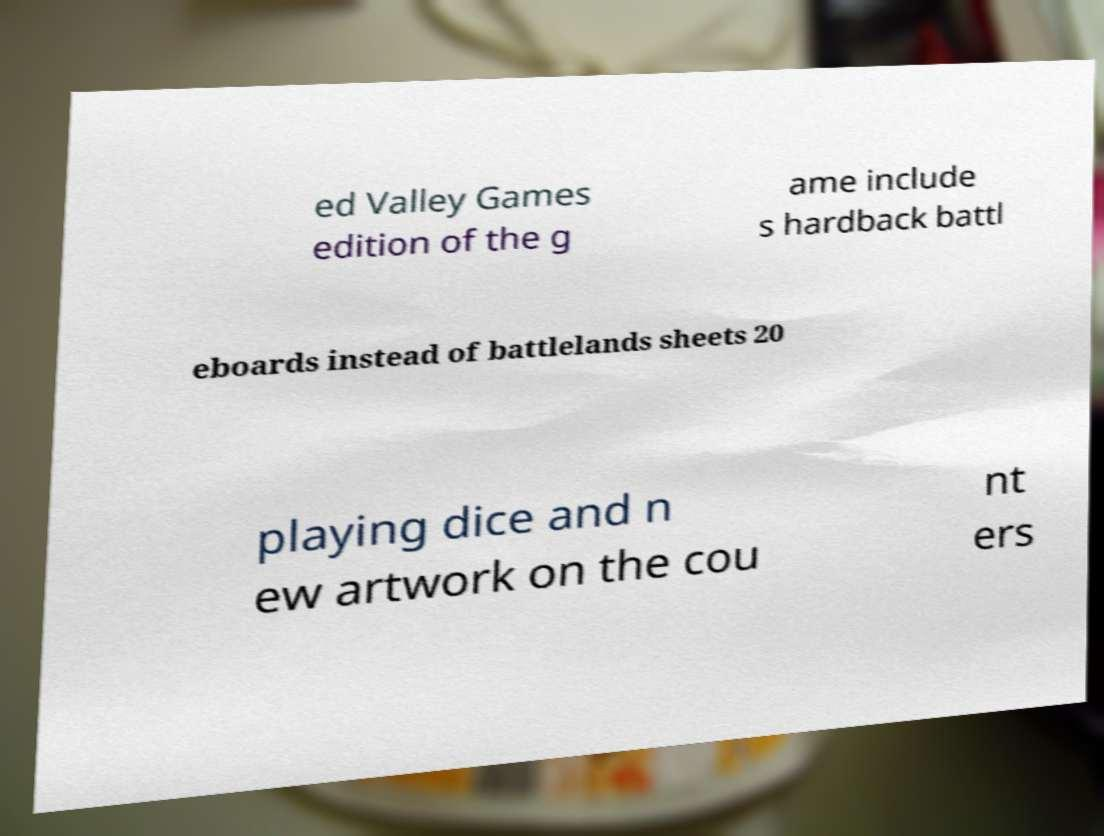There's text embedded in this image that I need extracted. Can you transcribe it verbatim? ed Valley Games edition of the g ame include s hardback battl eboards instead of battlelands sheets 20 playing dice and n ew artwork on the cou nt ers 